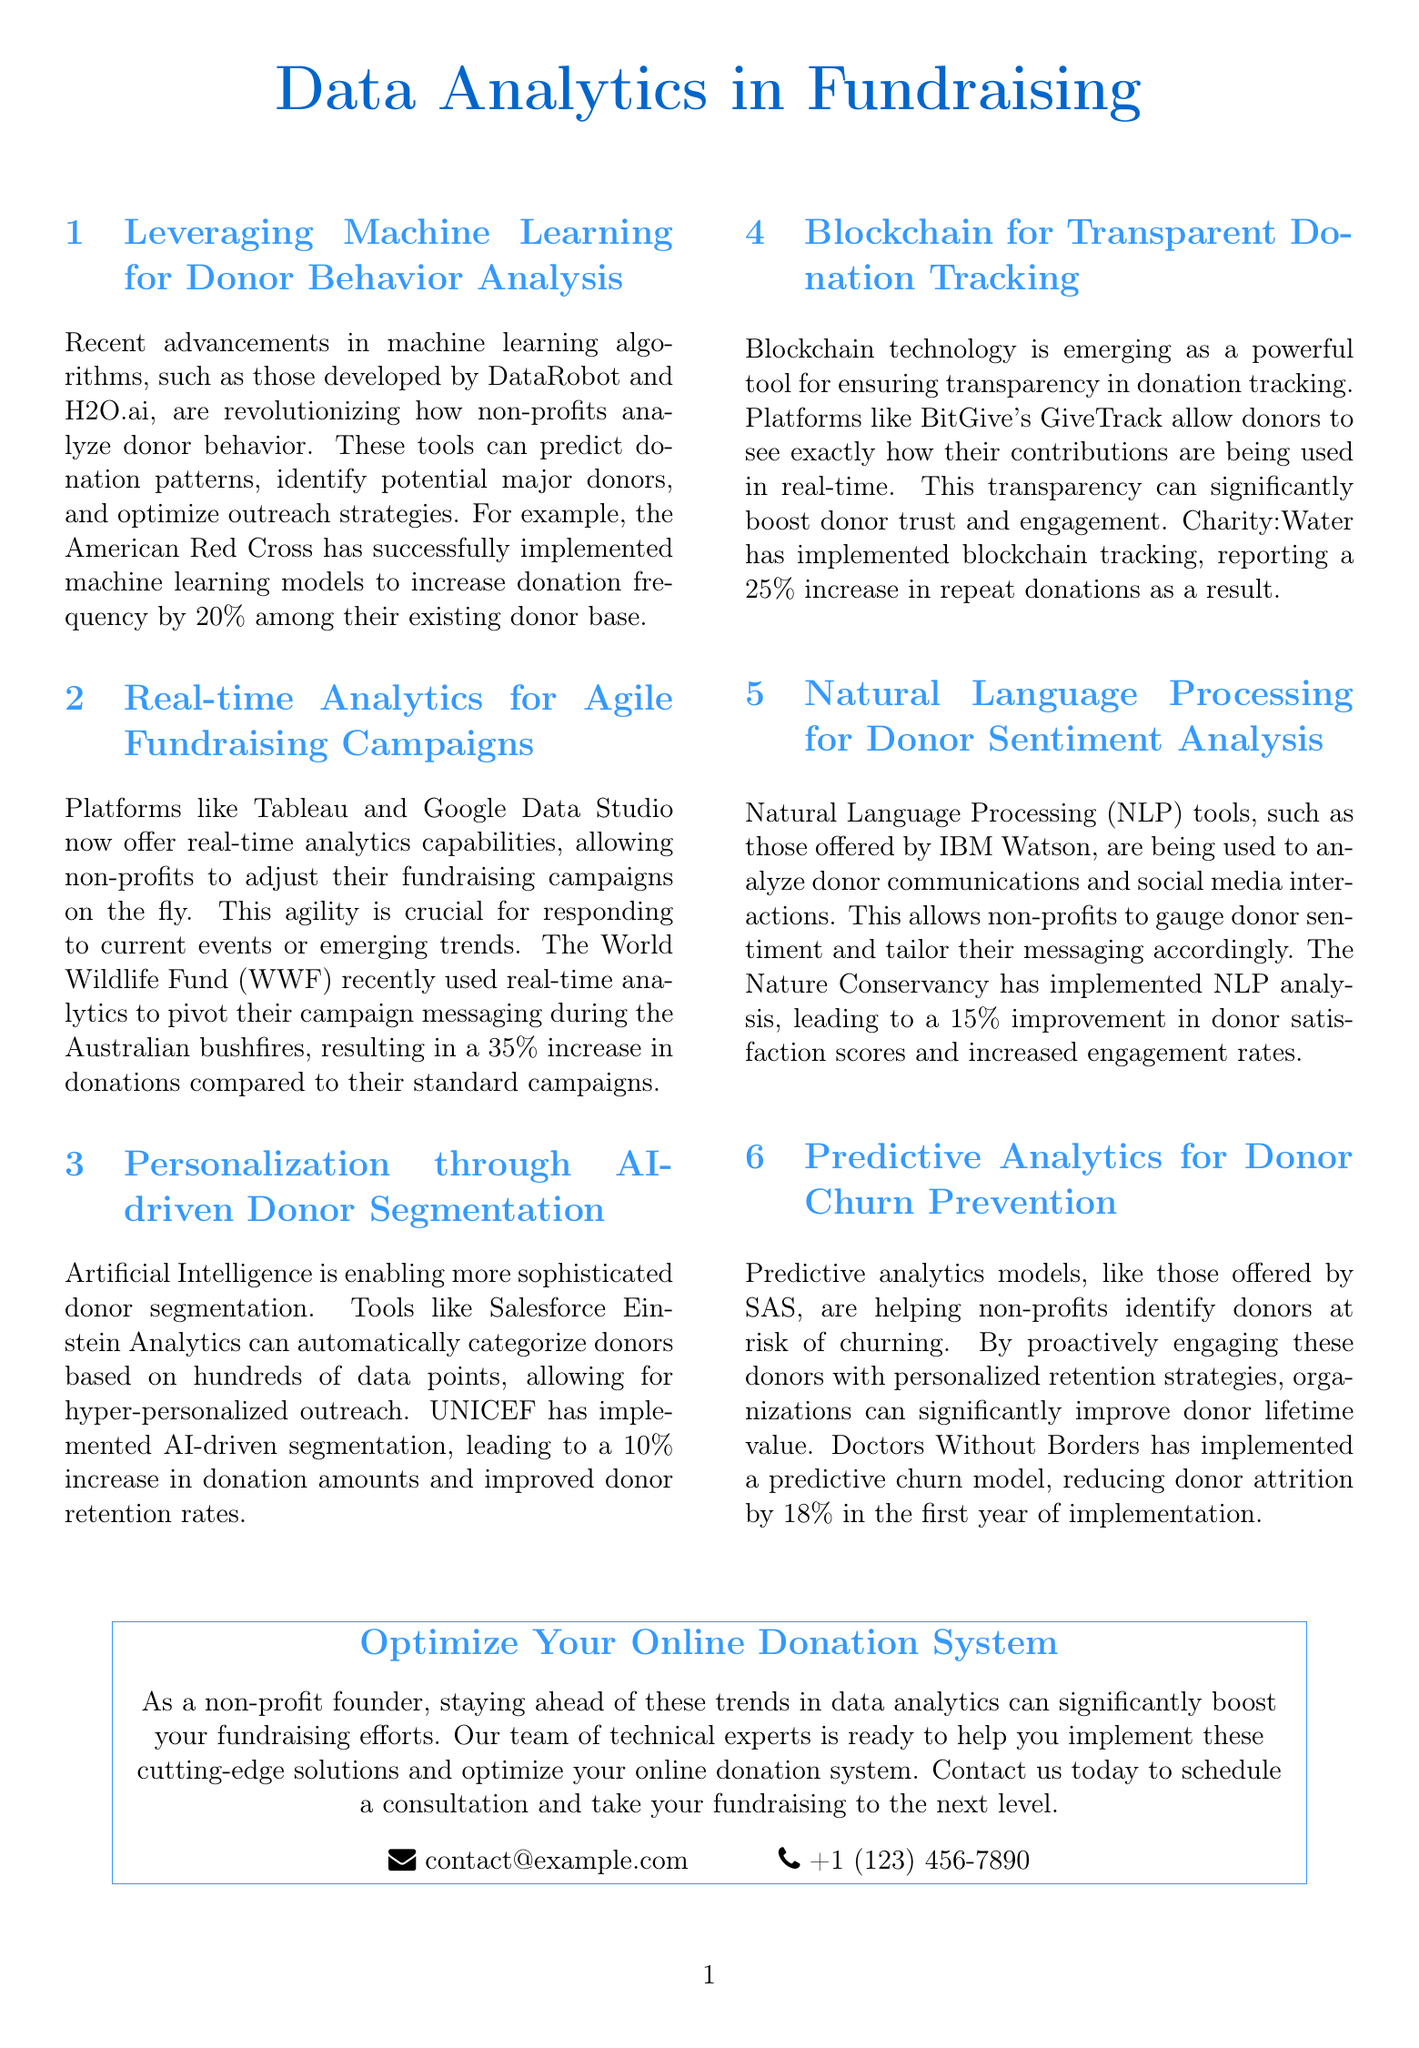What machine learning tools are mentioned for donor behavior analysis? The document mentions DataRobot and H2O.ai as tools for analyzing donor behavior.
Answer: DataRobot and H2O.ai By what percentage did the American Red Cross increase donation frequency? The document states that the American Red Cross implemented machine learning models to increase donation frequency by 20%.
Answer: 20% What real-time analytics platforms are listed? The document lists Tableau and Google Data Studio as platforms that offer real-time analytics capabilities.
Answer: Tableau and Google Data Studio What was the percentage increase in donations for the World Wildlife Fund's campaign during the bushfires? The document mentions that the WWF experienced a 35% increase in donations compared to their standard campaigns during the Australian bushfires.
Answer: 35% What technology is identified for ensuring transparency in donation tracking? The document identifies blockchain technology as a powerful tool for ensuring transparency in donation tracking.
Answer: Blockchain Which organization implemented AI-driven segmentation to improve donor retention? UNICEF is mentioned in the document as having implemented AI-driven segmentation.
Answer: UNICEF What was the reduction in donor attrition achieved by Doctors Without Borders through predictive analytics? The document states that Doctors Without Borders reduced donor attrition by 18% in the first year of implementation using predictive analytics.
Answer: 18% What tool is suggested for analyzing donor communications using Natural Language Processing? The document mentions IBM Watson as a tool used for analyzing donor communications and social media interactions.
Answer: IBM Watson What is the call to action in the newsletter? The call to action encourages readers to contact for consultation to optimize their online donation system.
Answer: Optimize Your Online Donation System 